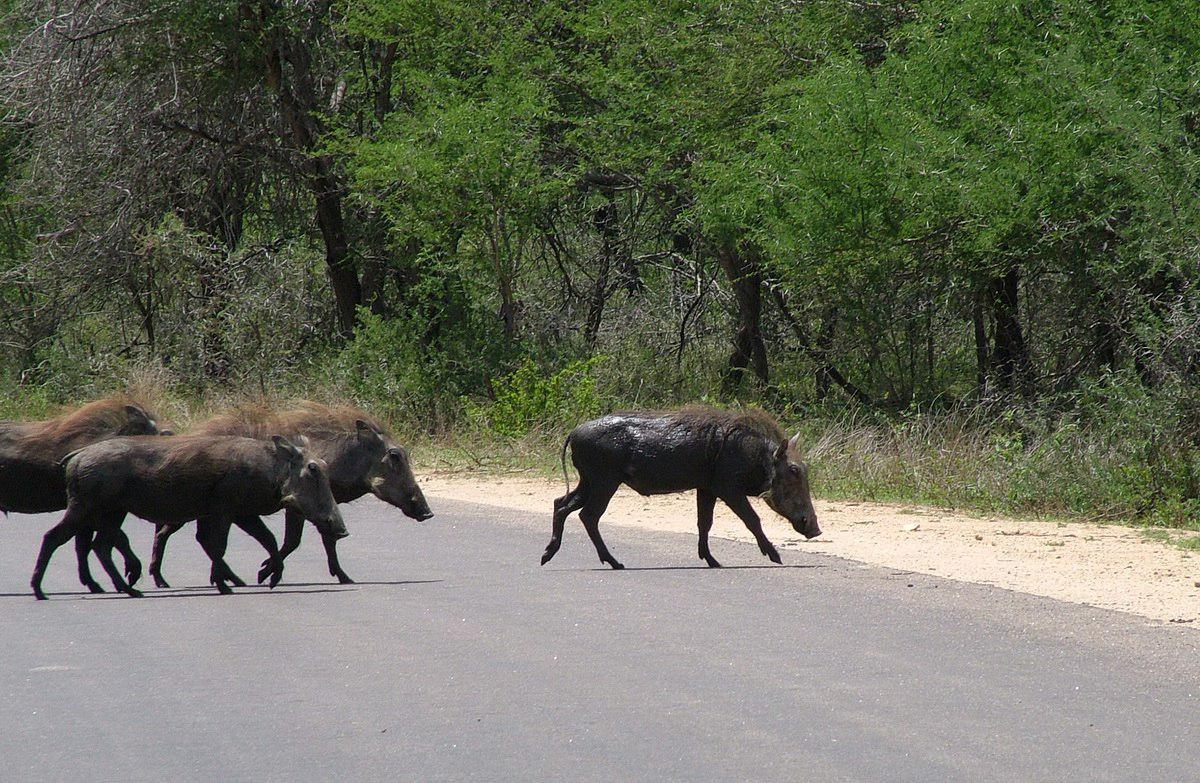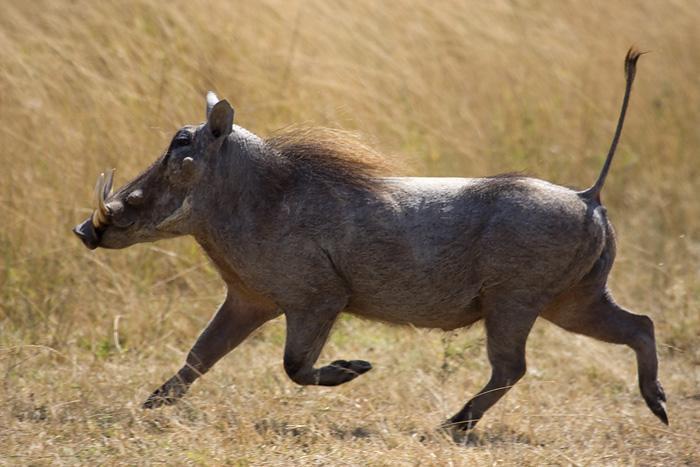The first image is the image on the left, the second image is the image on the right. Given the left and right images, does the statement "An image shows warthog on the left and spotted cat on the right." hold true? Answer yes or no. No. The first image is the image on the left, the second image is the image on the right. For the images shown, is this caption "There is a feline in one of the images." true? Answer yes or no. No. 